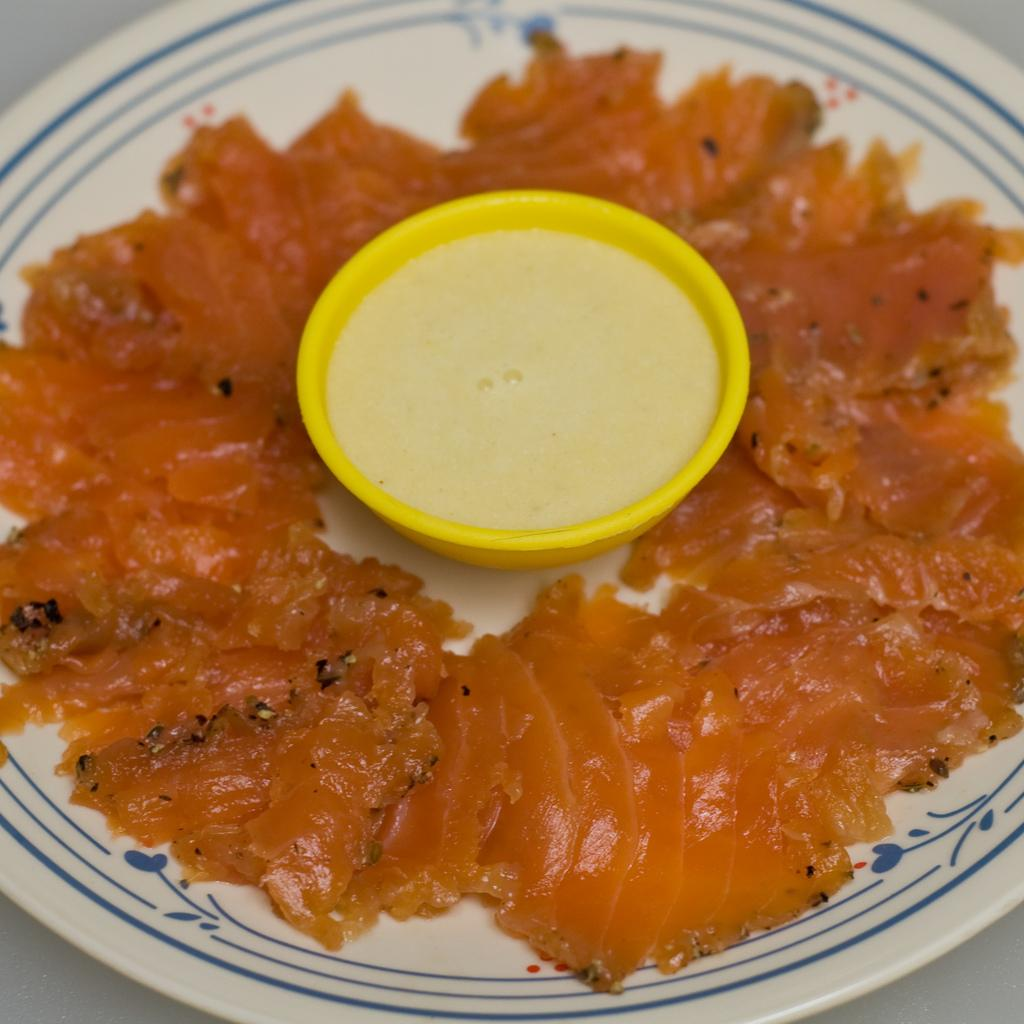What is on the plate in the image? There is food on the plate in the image. What is in the bowl in the image? There is liquid in the bowl in the image. Can you describe the background of the image? The background of the image might be a table. What type of drum is being played by the slave in the image? There is no drum or slave present in the image. What advice does the father give to his child in the image? There is no father or child present in the image. 